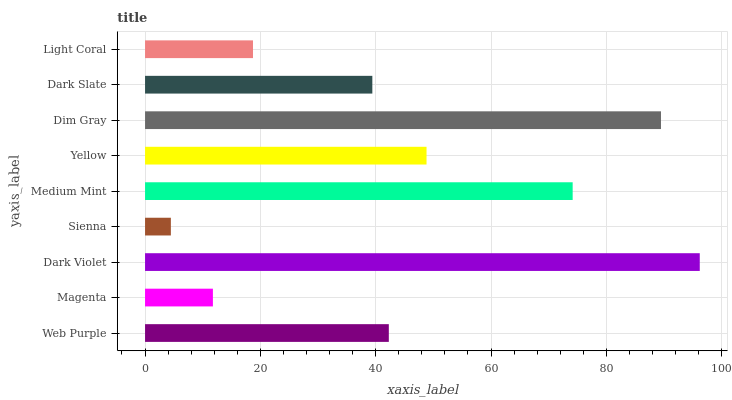Is Sienna the minimum?
Answer yes or no. Yes. Is Dark Violet the maximum?
Answer yes or no. Yes. Is Magenta the minimum?
Answer yes or no. No. Is Magenta the maximum?
Answer yes or no. No. Is Web Purple greater than Magenta?
Answer yes or no. Yes. Is Magenta less than Web Purple?
Answer yes or no. Yes. Is Magenta greater than Web Purple?
Answer yes or no. No. Is Web Purple less than Magenta?
Answer yes or no. No. Is Web Purple the high median?
Answer yes or no. Yes. Is Web Purple the low median?
Answer yes or no. Yes. Is Dim Gray the high median?
Answer yes or no. No. Is Magenta the low median?
Answer yes or no. No. 